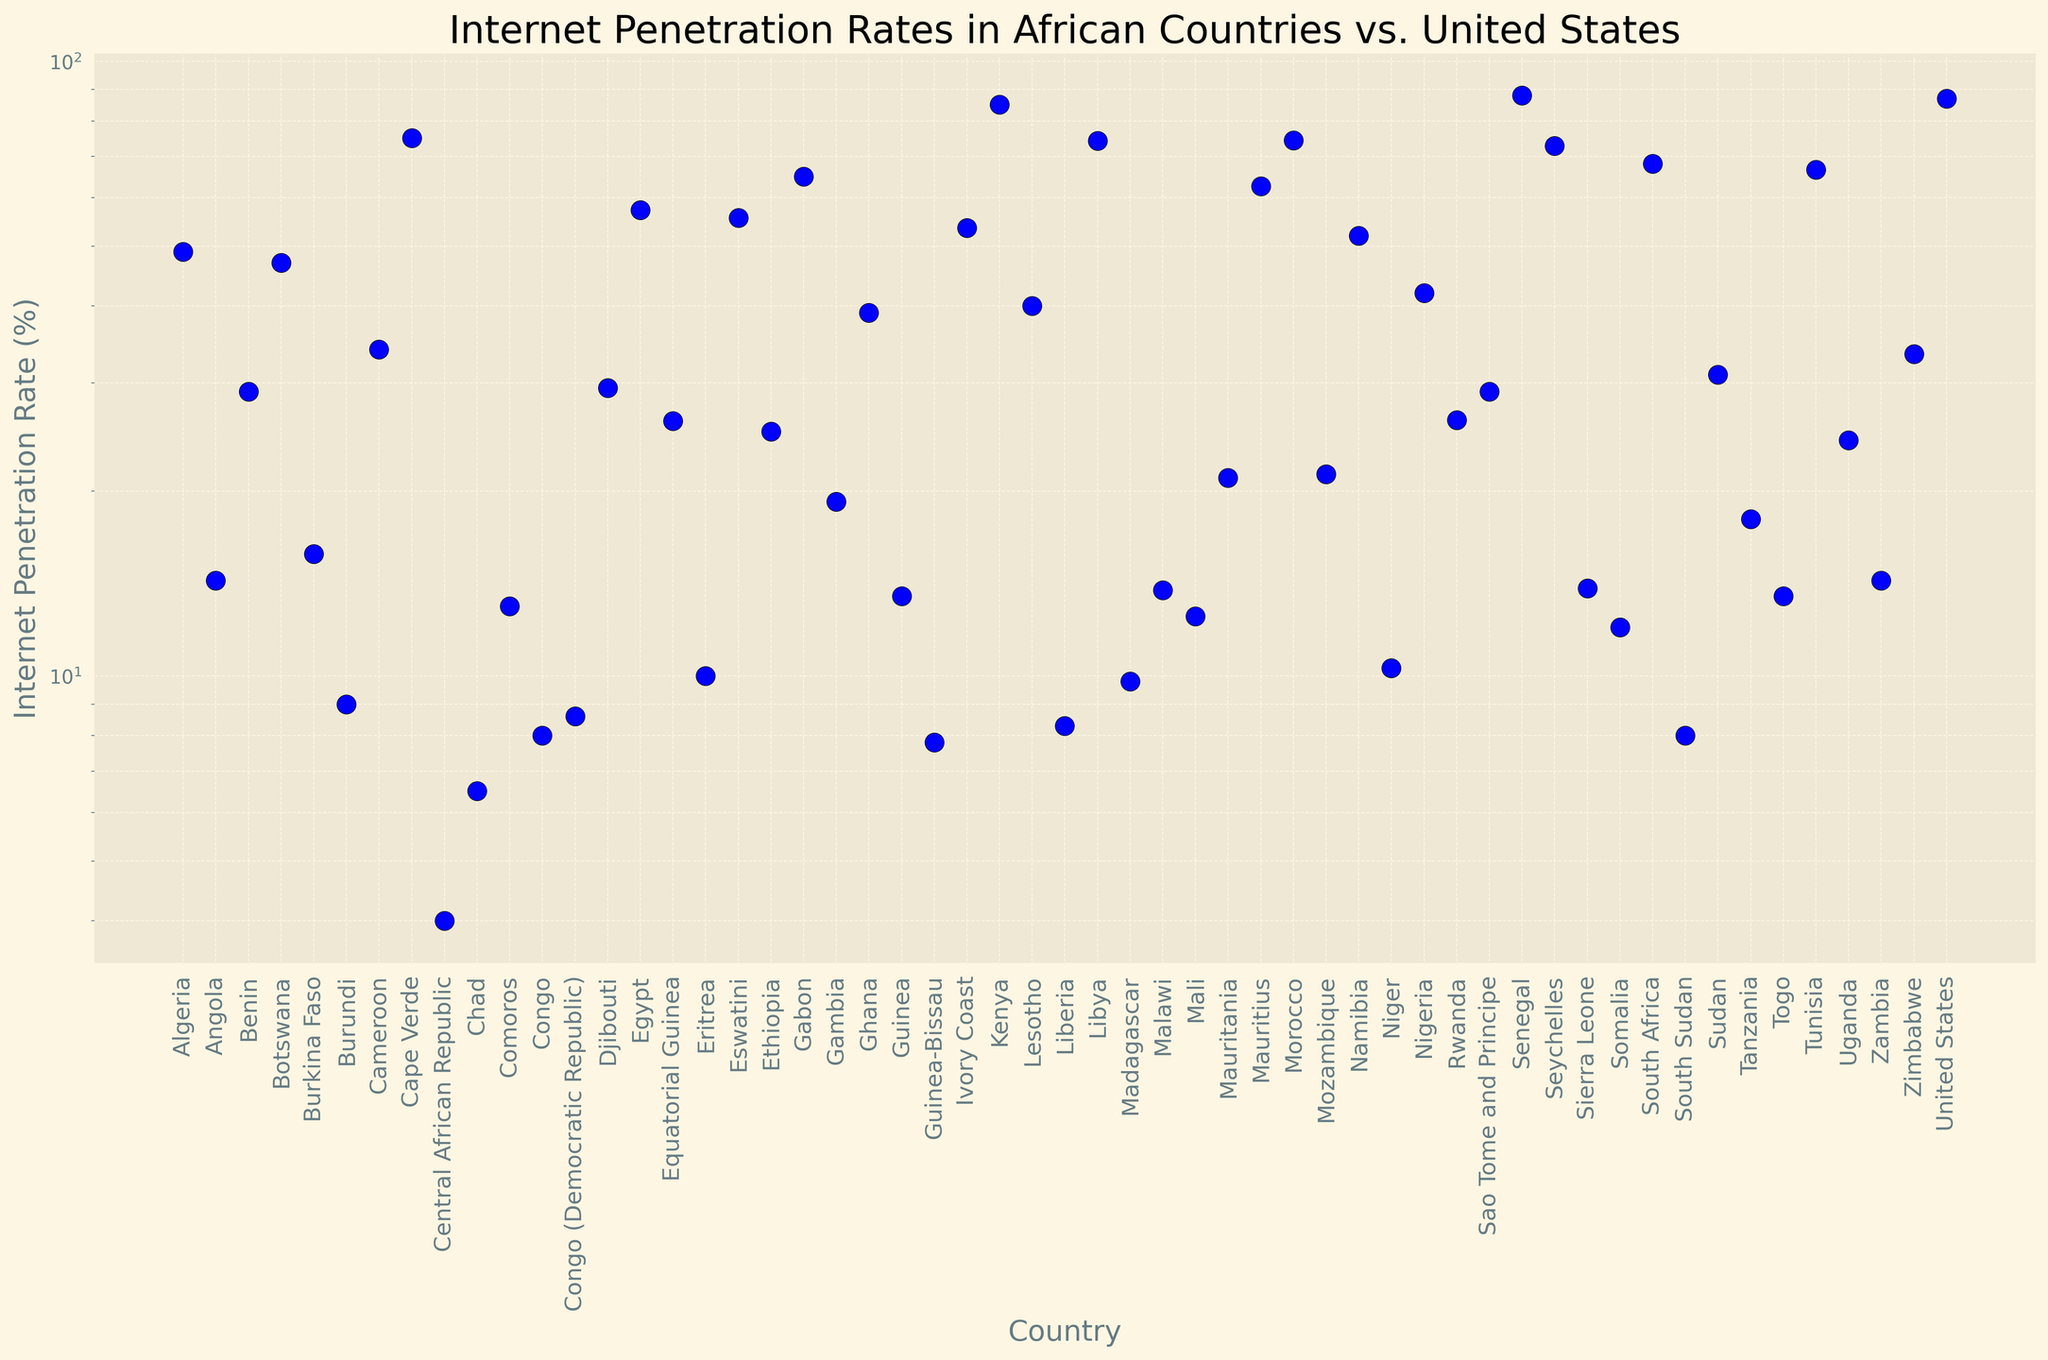Which country has the highest internet penetration rate? Look at the topmost data point on the plot and identify the corresponding country.
Answer: Senegal Which country has the lowest internet penetration rate among African countries? Look at the bottommost data point on the plot and identify the corresponding country.
Answer: Central African Republic How does the internet penetration rate in Kenya compare to that in the United States? Find Kenya and the United States on the x-axis and compare their y-axis values.
Answer: Kenya's rate is slightly higher than the United States What is the average internet penetration rate of Nigeria and South Africa? Locate Nigeria and South Africa on the x-axis; add their penetration rates and divide by 2. (42 + 68.2)/2 = 55.1
Answer: 55.1 Which country has an internet penetration rate higher than 50% but lower than 60%? Look for data points that fall within the range of 50% to 60% on the y-axis and identify the corresponding countries.
Answer: Egypt, Ivory Coast Is the internet penetration rate in Morocco greater or less than in Gabon? Find Morocco and Gabon on the x-axis and compare their y-axis values.
Answer: Less What is the range of internet penetration rates among these countries? Identify the highest and lowest values on the y-axis and subtract the lowest from the highest. 88.0 (Senegal) - 4.0 (Central African Republic) = 84.0
Answer: 84.0 Among the listed countries, which one falls closest to a 30% internet penetration rate? Locate 30% on the y-axis and find the nearest data point.
Answer: Cameroon How many countries have an internet penetration rate of less than 10%? Count the number of data points below the 10% mark on the y-axis.
Answer: 6 What is the difference in internet penetration rates between Tunisia and Madagascar? Locate Tunisia and Madagascar on the x-axis; subtract the penetration rate of Madagascar from that of Tunisia. 66.7 - 9.8 = 56.9
Answer: 56.9 